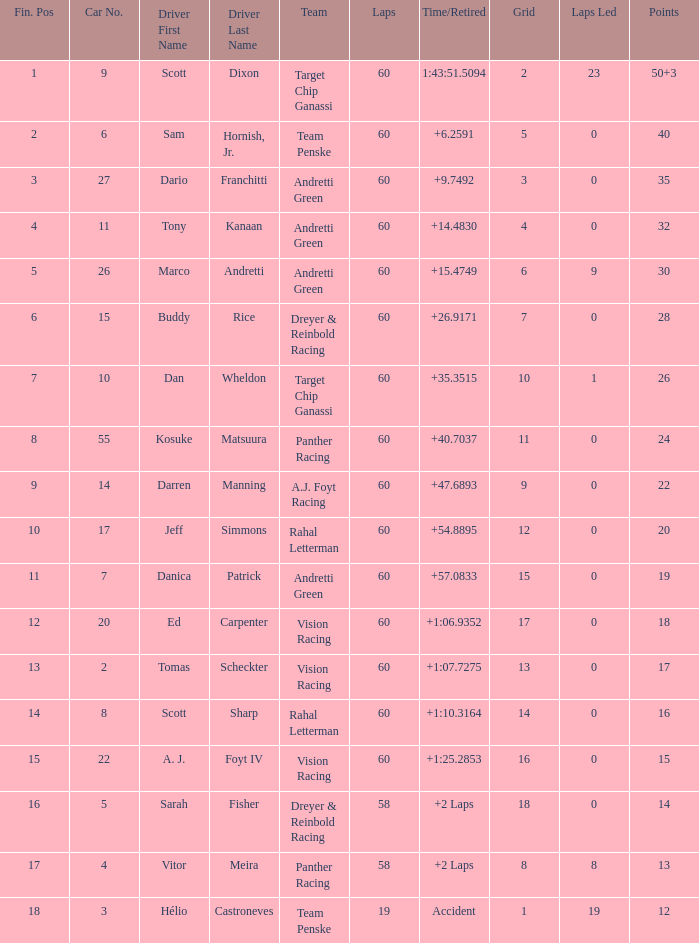Name the total number of grid for 30 1.0. 